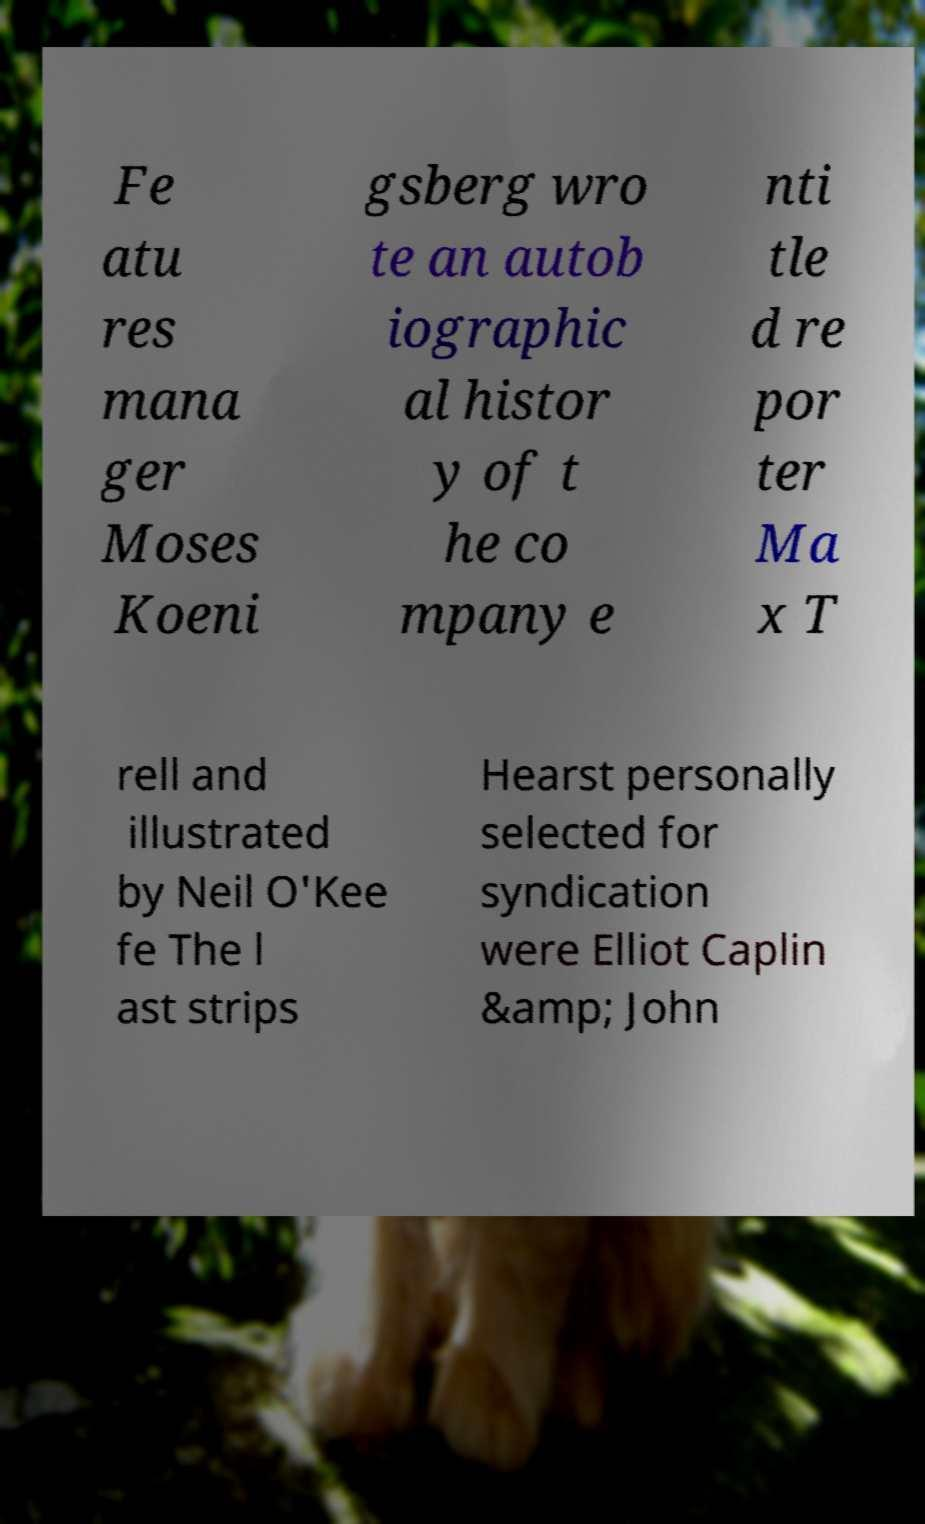Please identify and transcribe the text found in this image. Fe atu res mana ger Moses Koeni gsberg wro te an autob iographic al histor y of t he co mpany e nti tle d re por ter Ma x T rell and illustrated by Neil O'Kee fe The l ast strips Hearst personally selected for syndication were Elliot Caplin &amp; John 